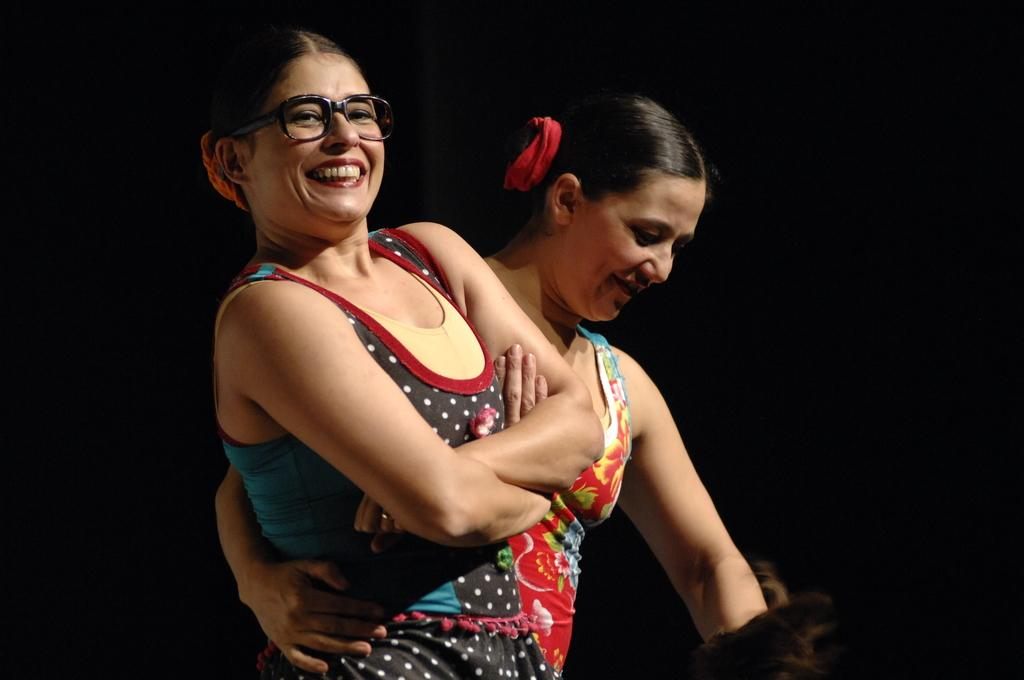How many women are in the image? There are two women in the image. What expressions do the women have? Both women are smiling. Can you describe the appearance of the woman on the left side? The woman on the left side is wearing spectacles. What type of yam is the woman on the right side holding in the image? There is no yam present in the image; both women are smiling and the woman on the left side is wearing spectacles. 